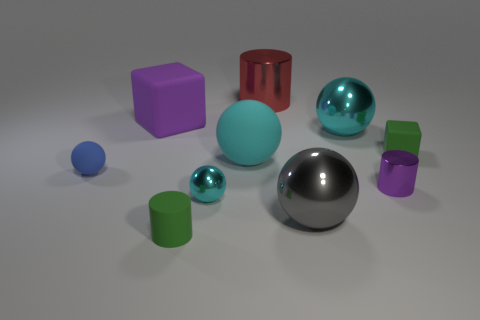Is the size of the purple matte thing the same as the red cylinder?
Provide a succinct answer. Yes. What shape is the tiny blue object that is made of the same material as the tiny green block?
Your answer should be very brief. Sphere. How many other things are the same shape as the small cyan shiny object?
Provide a succinct answer. 4. What shape is the purple matte thing left of the big cyan ball behind the matte block that is to the right of the large gray metal thing?
Your answer should be compact. Cube. What number of cubes are brown things or large red things?
Your answer should be compact. 0. There is a cyan metal object that is on the right side of the large rubber sphere; are there any purple cylinders behind it?
Your answer should be very brief. No. Is there any other thing that is made of the same material as the purple cylinder?
Ensure brevity in your answer.  Yes. There is a gray object; is its shape the same as the green object that is in front of the small blue rubber object?
Keep it short and to the point. No. What number of other things are the same size as the green cylinder?
Provide a succinct answer. 4. How many cyan objects are tiny balls or large metallic objects?
Your answer should be very brief. 2. 